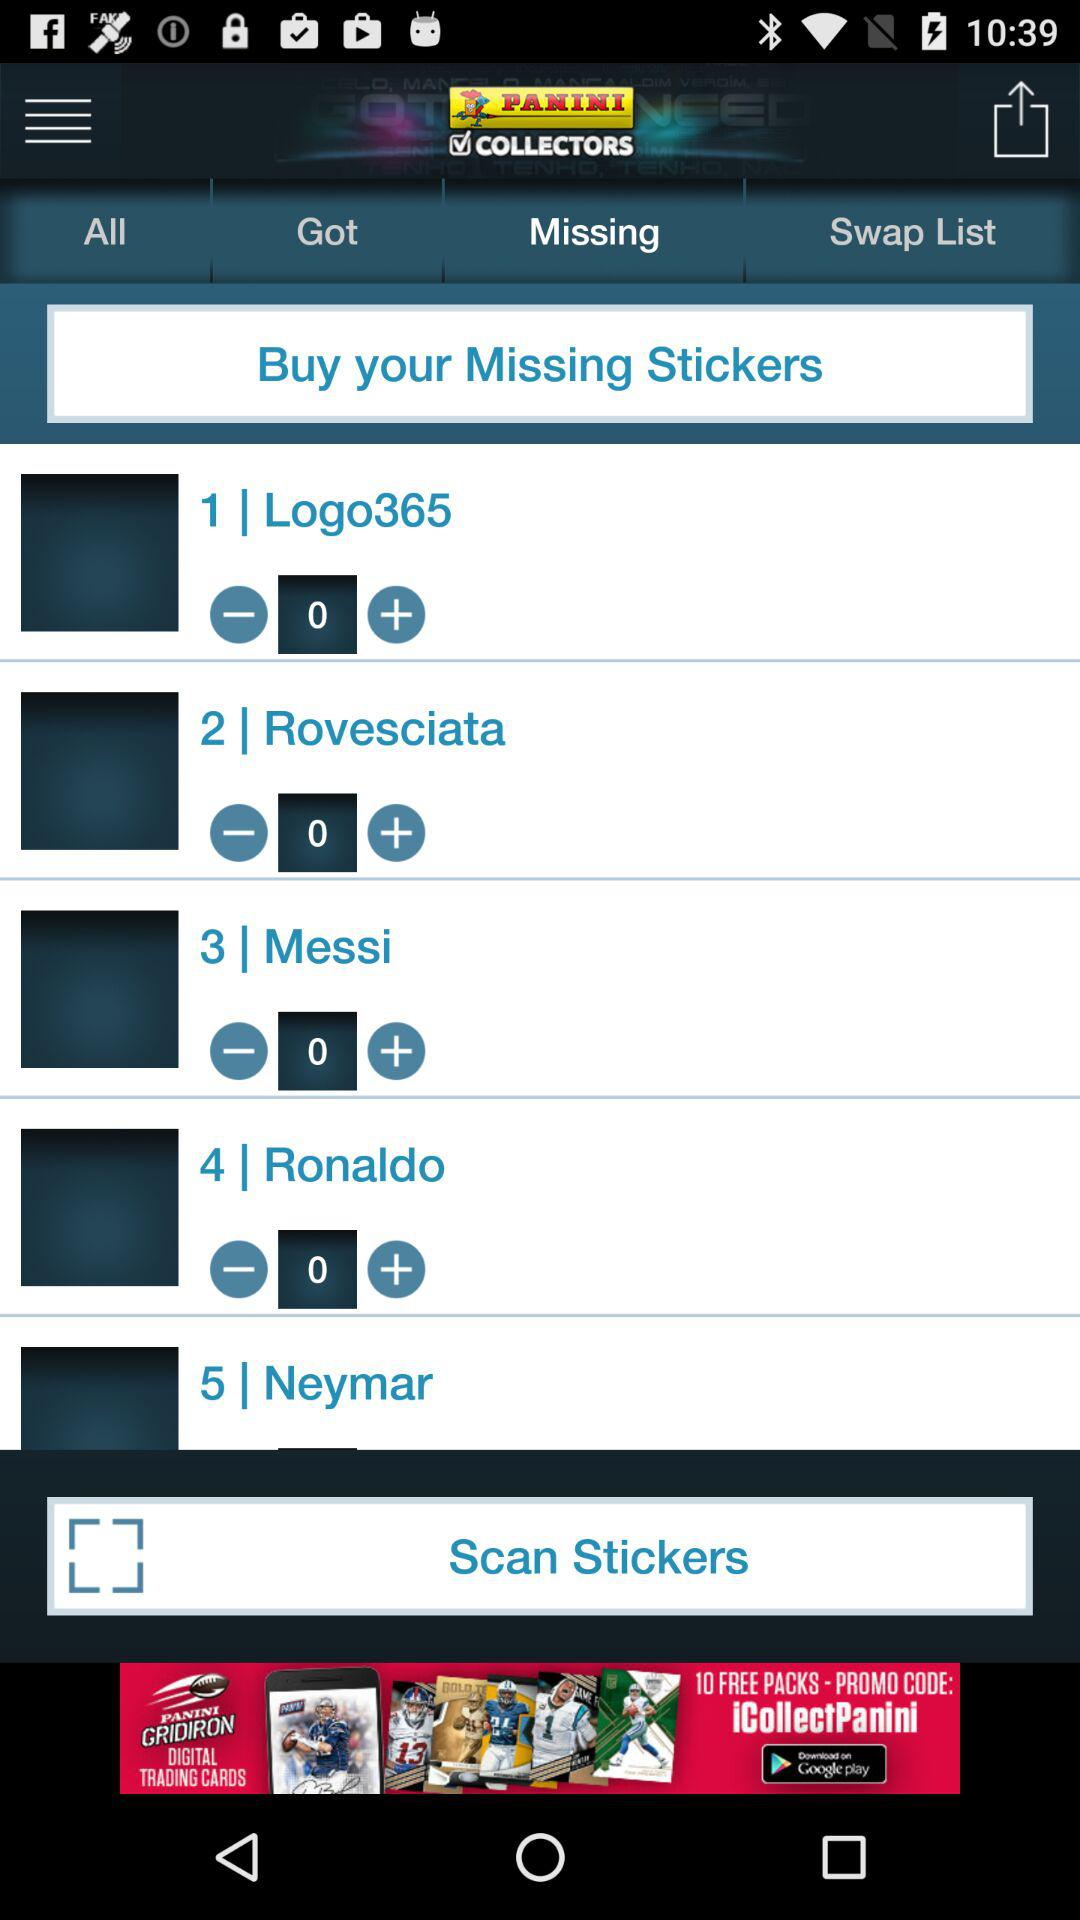What is the application name? The application name is "PANINI COLLECTORS". 